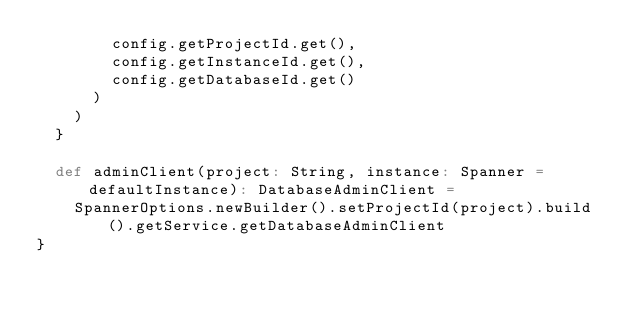<code> <loc_0><loc_0><loc_500><loc_500><_Scala_>        config.getProjectId.get(),
        config.getInstanceId.get(),
        config.getDatabaseId.get()
      )
    )
  }

  def adminClient(project: String, instance: Spanner = defaultInstance): DatabaseAdminClient =
    SpannerOptions.newBuilder().setProjectId(project).build().getService.getDatabaseAdminClient
}
</code> 